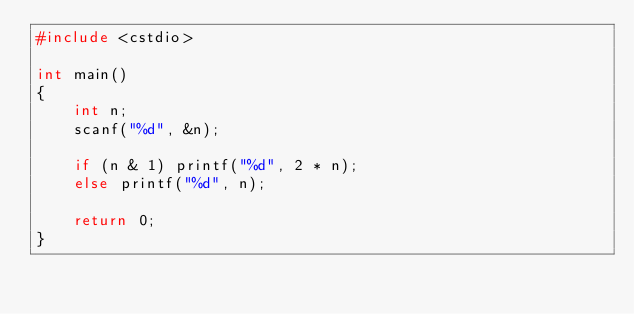Convert code to text. <code><loc_0><loc_0><loc_500><loc_500><_C++_>#include <cstdio>

int main()
{
	int n;
	scanf("%d", &n);

	if (n & 1) printf("%d", 2 * n);
	else printf("%d", n);

	return 0;
}</code> 